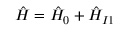<formula> <loc_0><loc_0><loc_500><loc_500>\hat { H } = \hat { H } _ { 0 } + \hat { H } _ { I 1 }</formula> 